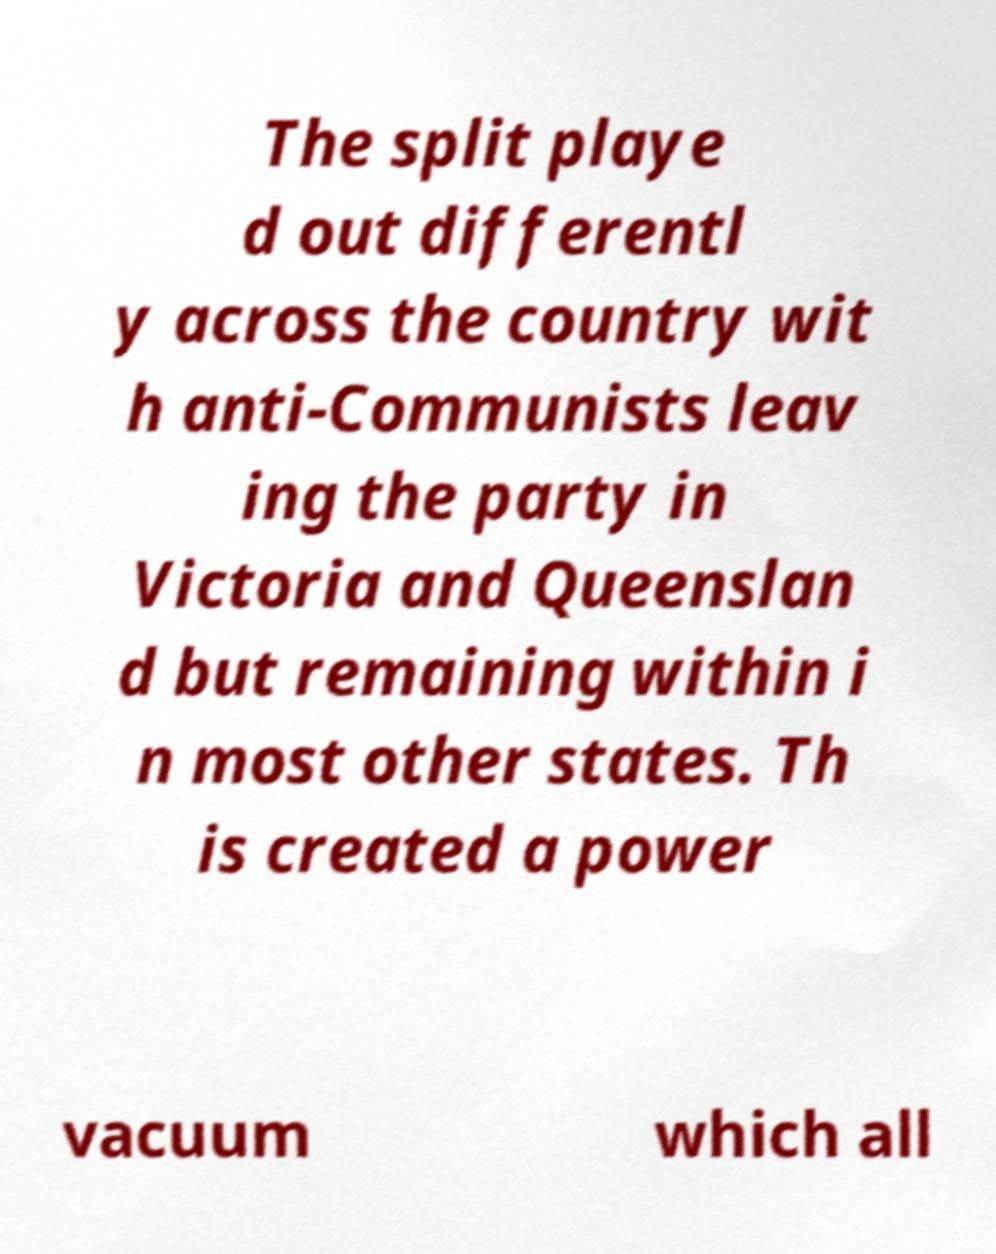Can you accurately transcribe the text from the provided image for me? The split playe d out differentl y across the country wit h anti-Communists leav ing the party in Victoria and Queenslan d but remaining within i n most other states. Th is created a power vacuum which all 